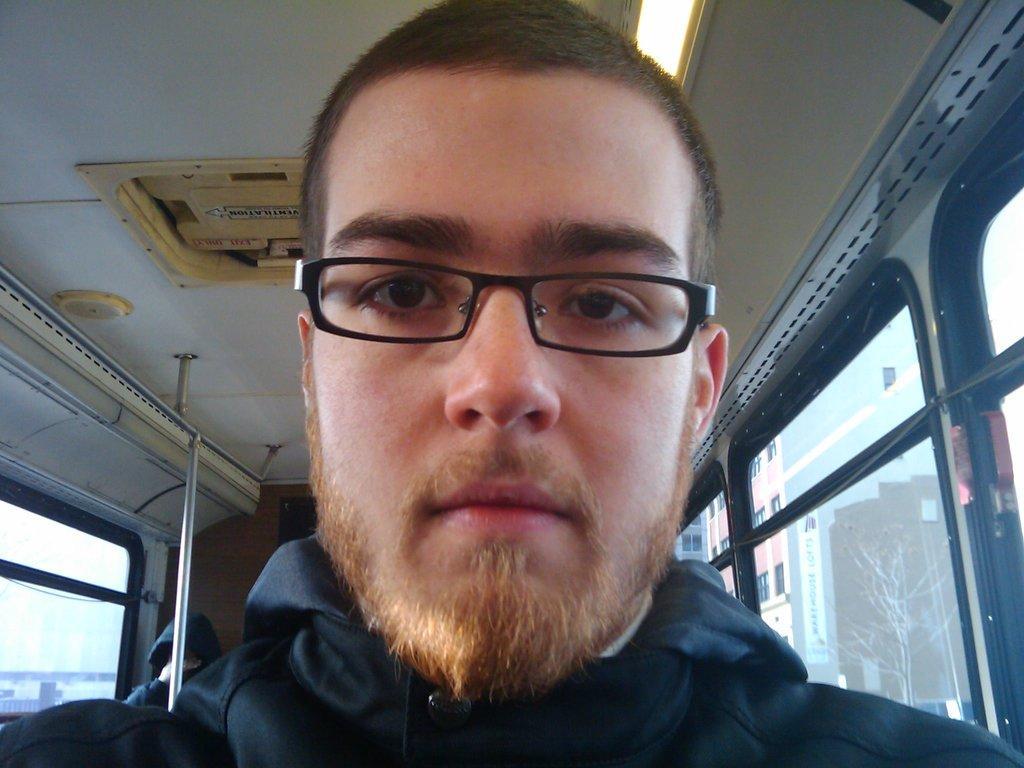Could you give a brief overview of what you see in this image? This is inside of a vehicle, there is a man wore spectacle. We can see glass windows, pole and person, through these windows we can see buildings, trees and sky. 